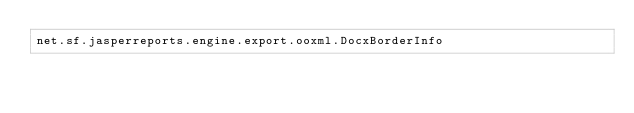Convert code to text. <code><loc_0><loc_0><loc_500><loc_500><_Rust_>net.sf.jasperreports.engine.export.ooxml.DocxBorderInfo
</code> 